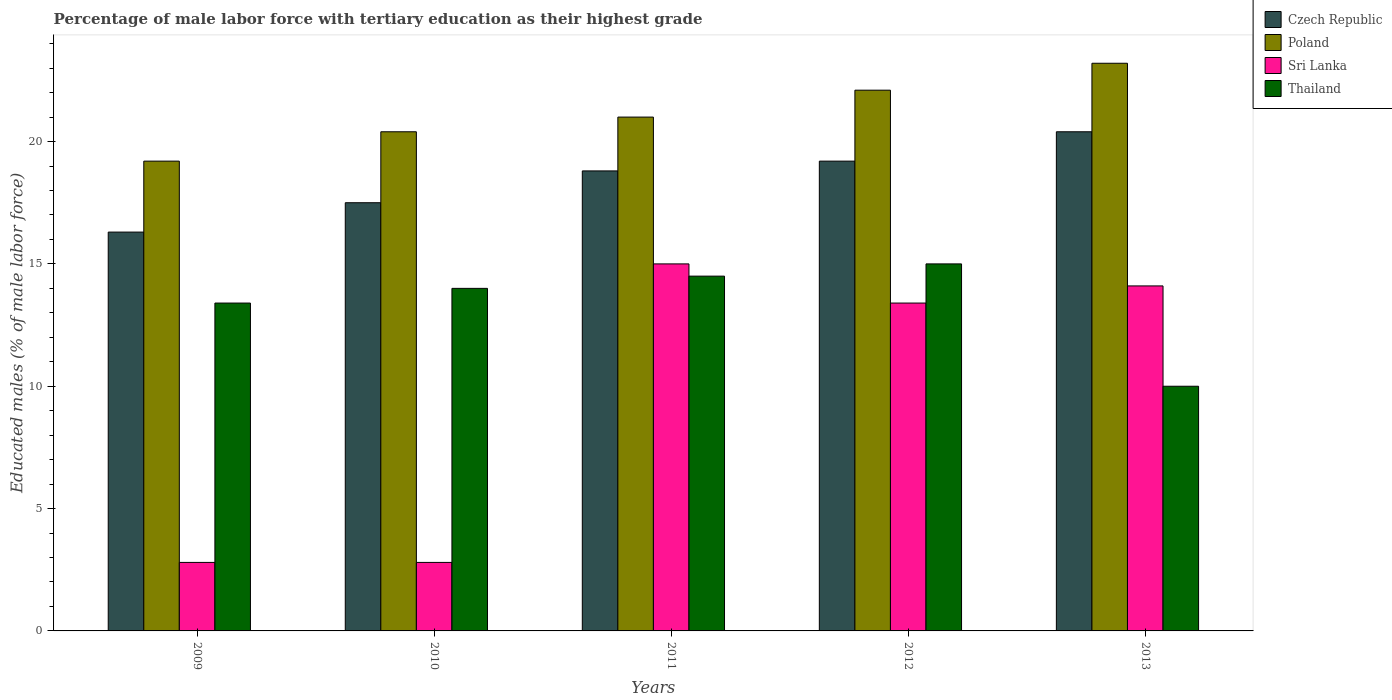How many bars are there on the 1st tick from the left?
Your answer should be very brief. 4. How many bars are there on the 5th tick from the right?
Keep it short and to the point. 4. What is the label of the 3rd group of bars from the left?
Provide a short and direct response. 2011. In how many cases, is the number of bars for a given year not equal to the number of legend labels?
Ensure brevity in your answer.  0. What is the percentage of male labor force with tertiary education in Poland in 2012?
Your response must be concise. 22.1. Across all years, what is the maximum percentage of male labor force with tertiary education in Poland?
Offer a terse response. 23.2. Across all years, what is the minimum percentage of male labor force with tertiary education in Poland?
Keep it short and to the point. 19.2. In which year was the percentage of male labor force with tertiary education in Poland maximum?
Your answer should be compact. 2013. In which year was the percentage of male labor force with tertiary education in Sri Lanka minimum?
Make the answer very short. 2009. What is the total percentage of male labor force with tertiary education in Thailand in the graph?
Provide a short and direct response. 66.9. What is the difference between the percentage of male labor force with tertiary education in Thailand in 2010 and that in 2012?
Give a very brief answer. -1. What is the difference between the percentage of male labor force with tertiary education in Thailand in 2011 and the percentage of male labor force with tertiary education in Czech Republic in 2013?
Ensure brevity in your answer.  -5.9. What is the average percentage of male labor force with tertiary education in Thailand per year?
Provide a succinct answer. 13.38. In the year 2011, what is the difference between the percentage of male labor force with tertiary education in Thailand and percentage of male labor force with tertiary education in Czech Republic?
Offer a terse response. -4.3. What is the ratio of the percentage of male labor force with tertiary education in Sri Lanka in 2011 to that in 2012?
Offer a very short reply. 1.12. Is the percentage of male labor force with tertiary education in Poland in 2010 less than that in 2013?
Your answer should be compact. Yes. Is the difference between the percentage of male labor force with tertiary education in Thailand in 2009 and 2010 greater than the difference between the percentage of male labor force with tertiary education in Czech Republic in 2009 and 2010?
Your response must be concise. Yes. What is the difference between the highest and the second highest percentage of male labor force with tertiary education in Sri Lanka?
Offer a terse response. 0.9. What is the difference between the highest and the lowest percentage of male labor force with tertiary education in Czech Republic?
Provide a succinct answer. 4.1. In how many years, is the percentage of male labor force with tertiary education in Poland greater than the average percentage of male labor force with tertiary education in Poland taken over all years?
Provide a succinct answer. 2. Is it the case that in every year, the sum of the percentage of male labor force with tertiary education in Poland and percentage of male labor force with tertiary education in Czech Republic is greater than the sum of percentage of male labor force with tertiary education in Thailand and percentage of male labor force with tertiary education in Sri Lanka?
Provide a succinct answer. Yes. What does the 4th bar from the right in 2013 represents?
Keep it short and to the point. Czech Republic. How many bars are there?
Make the answer very short. 20. Are all the bars in the graph horizontal?
Give a very brief answer. No. How many years are there in the graph?
Make the answer very short. 5. Are the values on the major ticks of Y-axis written in scientific E-notation?
Offer a very short reply. No. Does the graph contain grids?
Offer a terse response. No. What is the title of the graph?
Your answer should be very brief. Percentage of male labor force with tertiary education as their highest grade. Does "Russian Federation" appear as one of the legend labels in the graph?
Provide a succinct answer. No. What is the label or title of the Y-axis?
Offer a very short reply. Educated males (% of male labor force). What is the Educated males (% of male labor force) in Czech Republic in 2009?
Your response must be concise. 16.3. What is the Educated males (% of male labor force) of Poland in 2009?
Provide a short and direct response. 19.2. What is the Educated males (% of male labor force) in Sri Lanka in 2009?
Give a very brief answer. 2.8. What is the Educated males (% of male labor force) of Thailand in 2009?
Provide a succinct answer. 13.4. What is the Educated males (% of male labor force) of Poland in 2010?
Provide a short and direct response. 20.4. What is the Educated males (% of male labor force) of Sri Lanka in 2010?
Offer a terse response. 2.8. What is the Educated males (% of male labor force) in Czech Republic in 2011?
Your answer should be compact. 18.8. What is the Educated males (% of male labor force) of Poland in 2011?
Your answer should be compact. 21. What is the Educated males (% of male labor force) in Sri Lanka in 2011?
Your answer should be compact. 15. What is the Educated males (% of male labor force) of Thailand in 2011?
Make the answer very short. 14.5. What is the Educated males (% of male labor force) in Czech Republic in 2012?
Keep it short and to the point. 19.2. What is the Educated males (% of male labor force) of Poland in 2012?
Your answer should be compact. 22.1. What is the Educated males (% of male labor force) of Sri Lanka in 2012?
Make the answer very short. 13.4. What is the Educated males (% of male labor force) of Thailand in 2012?
Provide a short and direct response. 15. What is the Educated males (% of male labor force) of Czech Republic in 2013?
Provide a short and direct response. 20.4. What is the Educated males (% of male labor force) in Poland in 2013?
Make the answer very short. 23.2. What is the Educated males (% of male labor force) of Sri Lanka in 2013?
Offer a terse response. 14.1. Across all years, what is the maximum Educated males (% of male labor force) in Czech Republic?
Your response must be concise. 20.4. Across all years, what is the maximum Educated males (% of male labor force) of Poland?
Provide a short and direct response. 23.2. Across all years, what is the maximum Educated males (% of male labor force) in Sri Lanka?
Offer a terse response. 15. Across all years, what is the minimum Educated males (% of male labor force) in Czech Republic?
Your response must be concise. 16.3. Across all years, what is the minimum Educated males (% of male labor force) in Poland?
Offer a very short reply. 19.2. Across all years, what is the minimum Educated males (% of male labor force) in Sri Lanka?
Offer a terse response. 2.8. What is the total Educated males (% of male labor force) of Czech Republic in the graph?
Your answer should be compact. 92.2. What is the total Educated males (% of male labor force) in Poland in the graph?
Your answer should be very brief. 105.9. What is the total Educated males (% of male labor force) in Sri Lanka in the graph?
Keep it short and to the point. 48.1. What is the total Educated males (% of male labor force) of Thailand in the graph?
Offer a very short reply. 66.9. What is the difference between the Educated males (% of male labor force) in Czech Republic in 2009 and that in 2010?
Ensure brevity in your answer.  -1.2. What is the difference between the Educated males (% of male labor force) in Poland in 2009 and that in 2010?
Offer a very short reply. -1.2. What is the difference between the Educated males (% of male labor force) of Thailand in 2009 and that in 2010?
Your answer should be very brief. -0.6. What is the difference between the Educated males (% of male labor force) in Czech Republic in 2009 and that in 2011?
Ensure brevity in your answer.  -2.5. What is the difference between the Educated males (% of male labor force) in Czech Republic in 2009 and that in 2012?
Provide a succinct answer. -2.9. What is the difference between the Educated males (% of male labor force) of Poland in 2009 and that in 2012?
Offer a very short reply. -2.9. What is the difference between the Educated males (% of male labor force) in Czech Republic in 2009 and that in 2013?
Your answer should be compact. -4.1. What is the difference between the Educated males (% of male labor force) in Sri Lanka in 2010 and that in 2011?
Your answer should be compact. -12.2. What is the difference between the Educated males (% of male labor force) of Thailand in 2010 and that in 2011?
Provide a succinct answer. -0.5. What is the difference between the Educated males (% of male labor force) in Sri Lanka in 2010 and that in 2012?
Offer a very short reply. -10.6. What is the difference between the Educated males (% of male labor force) of Poland in 2010 and that in 2013?
Offer a very short reply. -2.8. What is the difference between the Educated males (% of male labor force) of Thailand in 2010 and that in 2013?
Offer a terse response. 4. What is the difference between the Educated males (% of male labor force) of Sri Lanka in 2011 and that in 2012?
Your answer should be compact. 1.6. What is the difference between the Educated males (% of male labor force) in Thailand in 2011 and that in 2012?
Give a very brief answer. -0.5. What is the difference between the Educated males (% of male labor force) in Poland in 2011 and that in 2013?
Give a very brief answer. -2.2. What is the difference between the Educated males (% of male labor force) of Sri Lanka in 2011 and that in 2013?
Your response must be concise. 0.9. What is the difference between the Educated males (% of male labor force) in Thailand in 2011 and that in 2013?
Make the answer very short. 4.5. What is the difference between the Educated males (% of male labor force) of Poland in 2012 and that in 2013?
Make the answer very short. -1.1. What is the difference between the Educated males (% of male labor force) in Sri Lanka in 2012 and that in 2013?
Your answer should be very brief. -0.7. What is the difference between the Educated males (% of male labor force) of Czech Republic in 2009 and the Educated males (% of male labor force) of Sri Lanka in 2010?
Give a very brief answer. 13.5. What is the difference between the Educated males (% of male labor force) in Poland in 2009 and the Educated males (% of male labor force) in Sri Lanka in 2010?
Ensure brevity in your answer.  16.4. What is the difference between the Educated males (% of male labor force) of Czech Republic in 2009 and the Educated males (% of male labor force) of Poland in 2011?
Provide a succinct answer. -4.7. What is the difference between the Educated males (% of male labor force) in Czech Republic in 2009 and the Educated males (% of male labor force) in Sri Lanka in 2011?
Ensure brevity in your answer.  1.3. What is the difference between the Educated males (% of male labor force) of Czech Republic in 2009 and the Educated males (% of male labor force) of Thailand in 2011?
Give a very brief answer. 1.8. What is the difference between the Educated males (% of male labor force) in Poland in 2009 and the Educated males (% of male labor force) in Thailand in 2011?
Ensure brevity in your answer.  4.7. What is the difference between the Educated males (% of male labor force) in Czech Republic in 2009 and the Educated males (% of male labor force) in Poland in 2012?
Ensure brevity in your answer.  -5.8. What is the difference between the Educated males (% of male labor force) of Poland in 2009 and the Educated males (% of male labor force) of Thailand in 2012?
Your answer should be compact. 4.2. What is the difference between the Educated males (% of male labor force) of Sri Lanka in 2009 and the Educated males (% of male labor force) of Thailand in 2012?
Offer a terse response. -12.2. What is the difference between the Educated males (% of male labor force) of Czech Republic in 2009 and the Educated males (% of male labor force) of Thailand in 2013?
Provide a succinct answer. 6.3. What is the difference between the Educated males (% of male labor force) of Poland in 2009 and the Educated males (% of male labor force) of Sri Lanka in 2013?
Make the answer very short. 5.1. What is the difference between the Educated males (% of male labor force) of Sri Lanka in 2009 and the Educated males (% of male labor force) of Thailand in 2013?
Give a very brief answer. -7.2. What is the difference between the Educated males (% of male labor force) in Czech Republic in 2010 and the Educated males (% of male labor force) in Thailand in 2011?
Your answer should be compact. 3. What is the difference between the Educated males (% of male labor force) of Poland in 2010 and the Educated males (% of male labor force) of Thailand in 2011?
Your answer should be very brief. 5.9. What is the difference between the Educated males (% of male labor force) in Sri Lanka in 2010 and the Educated males (% of male labor force) in Thailand in 2011?
Provide a succinct answer. -11.7. What is the difference between the Educated males (% of male labor force) of Poland in 2010 and the Educated males (% of male labor force) of Sri Lanka in 2012?
Keep it short and to the point. 7. What is the difference between the Educated males (% of male labor force) in Czech Republic in 2010 and the Educated males (% of male labor force) in Poland in 2013?
Offer a very short reply. -5.7. What is the difference between the Educated males (% of male labor force) of Czech Republic in 2010 and the Educated males (% of male labor force) of Sri Lanka in 2013?
Ensure brevity in your answer.  3.4. What is the difference between the Educated males (% of male labor force) of Poland in 2010 and the Educated males (% of male labor force) of Sri Lanka in 2013?
Provide a succinct answer. 6.3. What is the difference between the Educated males (% of male labor force) of Poland in 2010 and the Educated males (% of male labor force) of Thailand in 2013?
Offer a very short reply. 10.4. What is the difference between the Educated males (% of male labor force) in Sri Lanka in 2010 and the Educated males (% of male labor force) in Thailand in 2013?
Offer a terse response. -7.2. What is the difference between the Educated males (% of male labor force) in Czech Republic in 2011 and the Educated males (% of male labor force) in Poland in 2012?
Provide a succinct answer. -3.3. What is the difference between the Educated males (% of male labor force) of Czech Republic in 2011 and the Educated males (% of male labor force) of Sri Lanka in 2012?
Ensure brevity in your answer.  5.4. What is the difference between the Educated males (% of male labor force) in Czech Republic in 2011 and the Educated males (% of male labor force) in Thailand in 2012?
Your answer should be compact. 3.8. What is the difference between the Educated males (% of male labor force) of Sri Lanka in 2011 and the Educated males (% of male labor force) of Thailand in 2012?
Offer a terse response. 0. What is the difference between the Educated males (% of male labor force) in Czech Republic in 2011 and the Educated males (% of male labor force) in Poland in 2013?
Provide a succinct answer. -4.4. What is the difference between the Educated males (% of male labor force) of Poland in 2011 and the Educated males (% of male labor force) of Sri Lanka in 2013?
Your response must be concise. 6.9. What is the difference between the Educated males (% of male labor force) of Poland in 2011 and the Educated males (% of male labor force) of Thailand in 2013?
Make the answer very short. 11. What is the difference between the Educated males (% of male labor force) in Czech Republic in 2012 and the Educated males (% of male labor force) in Poland in 2013?
Give a very brief answer. -4. What is the difference between the Educated males (% of male labor force) of Czech Republic in 2012 and the Educated males (% of male labor force) of Sri Lanka in 2013?
Your answer should be very brief. 5.1. What is the difference between the Educated males (% of male labor force) in Poland in 2012 and the Educated males (% of male labor force) in Thailand in 2013?
Ensure brevity in your answer.  12.1. What is the difference between the Educated males (% of male labor force) in Sri Lanka in 2012 and the Educated males (% of male labor force) in Thailand in 2013?
Your answer should be very brief. 3.4. What is the average Educated males (% of male labor force) in Czech Republic per year?
Make the answer very short. 18.44. What is the average Educated males (% of male labor force) in Poland per year?
Keep it short and to the point. 21.18. What is the average Educated males (% of male labor force) in Sri Lanka per year?
Keep it short and to the point. 9.62. What is the average Educated males (% of male labor force) in Thailand per year?
Make the answer very short. 13.38. In the year 2009, what is the difference between the Educated males (% of male labor force) in Poland and Educated males (% of male labor force) in Sri Lanka?
Your answer should be very brief. 16.4. In the year 2009, what is the difference between the Educated males (% of male labor force) of Poland and Educated males (% of male labor force) of Thailand?
Your answer should be compact. 5.8. In the year 2010, what is the difference between the Educated males (% of male labor force) in Czech Republic and Educated males (% of male labor force) in Sri Lanka?
Offer a terse response. 14.7. In the year 2010, what is the difference between the Educated males (% of male labor force) of Czech Republic and Educated males (% of male labor force) of Thailand?
Provide a succinct answer. 3.5. In the year 2011, what is the difference between the Educated males (% of male labor force) of Czech Republic and Educated males (% of male labor force) of Sri Lanka?
Give a very brief answer. 3.8. In the year 2011, what is the difference between the Educated males (% of male labor force) in Czech Republic and Educated males (% of male labor force) in Thailand?
Your response must be concise. 4.3. In the year 2011, what is the difference between the Educated males (% of male labor force) in Poland and Educated males (% of male labor force) in Thailand?
Give a very brief answer. 6.5. In the year 2011, what is the difference between the Educated males (% of male labor force) in Sri Lanka and Educated males (% of male labor force) in Thailand?
Your answer should be very brief. 0.5. In the year 2012, what is the difference between the Educated males (% of male labor force) in Czech Republic and Educated males (% of male labor force) in Sri Lanka?
Make the answer very short. 5.8. In the year 2013, what is the difference between the Educated males (% of male labor force) of Czech Republic and Educated males (% of male labor force) of Poland?
Your answer should be compact. -2.8. In the year 2013, what is the difference between the Educated males (% of male labor force) of Czech Republic and Educated males (% of male labor force) of Thailand?
Your answer should be compact. 10.4. In the year 2013, what is the difference between the Educated males (% of male labor force) in Sri Lanka and Educated males (% of male labor force) in Thailand?
Make the answer very short. 4.1. What is the ratio of the Educated males (% of male labor force) of Czech Republic in 2009 to that in 2010?
Provide a short and direct response. 0.93. What is the ratio of the Educated males (% of male labor force) of Poland in 2009 to that in 2010?
Ensure brevity in your answer.  0.94. What is the ratio of the Educated males (% of male labor force) of Sri Lanka in 2009 to that in 2010?
Provide a short and direct response. 1. What is the ratio of the Educated males (% of male labor force) of Thailand in 2009 to that in 2010?
Provide a succinct answer. 0.96. What is the ratio of the Educated males (% of male labor force) in Czech Republic in 2009 to that in 2011?
Your response must be concise. 0.87. What is the ratio of the Educated males (% of male labor force) of Poland in 2009 to that in 2011?
Provide a short and direct response. 0.91. What is the ratio of the Educated males (% of male labor force) in Sri Lanka in 2009 to that in 2011?
Keep it short and to the point. 0.19. What is the ratio of the Educated males (% of male labor force) in Thailand in 2009 to that in 2011?
Ensure brevity in your answer.  0.92. What is the ratio of the Educated males (% of male labor force) in Czech Republic in 2009 to that in 2012?
Provide a short and direct response. 0.85. What is the ratio of the Educated males (% of male labor force) in Poland in 2009 to that in 2012?
Offer a very short reply. 0.87. What is the ratio of the Educated males (% of male labor force) of Sri Lanka in 2009 to that in 2012?
Your response must be concise. 0.21. What is the ratio of the Educated males (% of male labor force) in Thailand in 2009 to that in 2012?
Your answer should be compact. 0.89. What is the ratio of the Educated males (% of male labor force) of Czech Republic in 2009 to that in 2013?
Give a very brief answer. 0.8. What is the ratio of the Educated males (% of male labor force) in Poland in 2009 to that in 2013?
Your answer should be compact. 0.83. What is the ratio of the Educated males (% of male labor force) in Sri Lanka in 2009 to that in 2013?
Make the answer very short. 0.2. What is the ratio of the Educated males (% of male labor force) of Thailand in 2009 to that in 2013?
Keep it short and to the point. 1.34. What is the ratio of the Educated males (% of male labor force) of Czech Republic in 2010 to that in 2011?
Provide a succinct answer. 0.93. What is the ratio of the Educated males (% of male labor force) in Poland in 2010 to that in 2011?
Your answer should be compact. 0.97. What is the ratio of the Educated males (% of male labor force) of Sri Lanka in 2010 to that in 2011?
Your answer should be compact. 0.19. What is the ratio of the Educated males (% of male labor force) of Thailand in 2010 to that in 2011?
Your response must be concise. 0.97. What is the ratio of the Educated males (% of male labor force) of Czech Republic in 2010 to that in 2012?
Your response must be concise. 0.91. What is the ratio of the Educated males (% of male labor force) in Poland in 2010 to that in 2012?
Keep it short and to the point. 0.92. What is the ratio of the Educated males (% of male labor force) of Sri Lanka in 2010 to that in 2012?
Offer a very short reply. 0.21. What is the ratio of the Educated males (% of male labor force) of Czech Republic in 2010 to that in 2013?
Provide a succinct answer. 0.86. What is the ratio of the Educated males (% of male labor force) of Poland in 2010 to that in 2013?
Your response must be concise. 0.88. What is the ratio of the Educated males (% of male labor force) in Sri Lanka in 2010 to that in 2013?
Keep it short and to the point. 0.2. What is the ratio of the Educated males (% of male labor force) in Thailand in 2010 to that in 2013?
Provide a succinct answer. 1.4. What is the ratio of the Educated males (% of male labor force) of Czech Republic in 2011 to that in 2012?
Ensure brevity in your answer.  0.98. What is the ratio of the Educated males (% of male labor force) of Poland in 2011 to that in 2012?
Provide a short and direct response. 0.95. What is the ratio of the Educated males (% of male labor force) of Sri Lanka in 2011 to that in 2012?
Your answer should be compact. 1.12. What is the ratio of the Educated males (% of male labor force) in Thailand in 2011 to that in 2012?
Provide a succinct answer. 0.97. What is the ratio of the Educated males (% of male labor force) in Czech Republic in 2011 to that in 2013?
Your answer should be compact. 0.92. What is the ratio of the Educated males (% of male labor force) in Poland in 2011 to that in 2013?
Provide a succinct answer. 0.91. What is the ratio of the Educated males (% of male labor force) in Sri Lanka in 2011 to that in 2013?
Provide a short and direct response. 1.06. What is the ratio of the Educated males (% of male labor force) of Thailand in 2011 to that in 2013?
Provide a succinct answer. 1.45. What is the ratio of the Educated males (% of male labor force) in Czech Republic in 2012 to that in 2013?
Offer a very short reply. 0.94. What is the ratio of the Educated males (% of male labor force) in Poland in 2012 to that in 2013?
Give a very brief answer. 0.95. What is the ratio of the Educated males (% of male labor force) in Sri Lanka in 2012 to that in 2013?
Ensure brevity in your answer.  0.95. What is the difference between the highest and the second highest Educated males (% of male labor force) in Czech Republic?
Offer a very short reply. 1.2. What is the difference between the highest and the second highest Educated males (% of male labor force) in Poland?
Provide a short and direct response. 1.1. What is the difference between the highest and the lowest Educated males (% of male labor force) of Sri Lanka?
Offer a terse response. 12.2. What is the difference between the highest and the lowest Educated males (% of male labor force) of Thailand?
Make the answer very short. 5. 